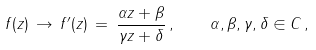<formula> <loc_0><loc_0><loc_500><loc_500>f ( z ) \, \to \, f ^ { \prime } ( z ) \, = \, \frac { \alpha z + \beta } { \gamma z + \delta } \, , \quad \alpha , \beta , \gamma , \delta \in C \, ,</formula> 